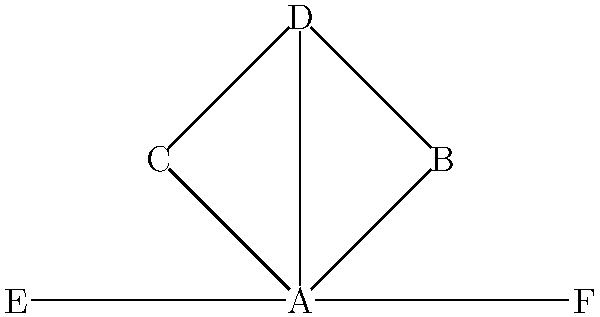In the influencer collaboration network shown above, which influencer has the highest degree centrality (i.e., the most direct connections to other influencers)? To determine the influencer with the highest degree centrality, we need to count the number of direct connections (edges) for each node in the network. Let's go through this step-by-step:

1. Count connections for each influencer:
   - Influencer A: 5 connections (to B, C, D, E, and F)
   - Influencer B: 2 connections (to A and D)
   - Influencer C: 2 connections (to A and D)
   - Influencer D: 3 connections (to A, B, and C)
   - Influencer E: 1 connection (to A)
   - Influencer F: 1 connection (to A)

2. Compare the number of connections:
   The highest number of connections is 5.

3. Identify the influencer with the highest degree centrality:
   Influencer A has 5 connections, which is the highest among all influencers in the network.

Therefore, Influencer A has the highest degree centrality in this collaboration network.
Answer: A 